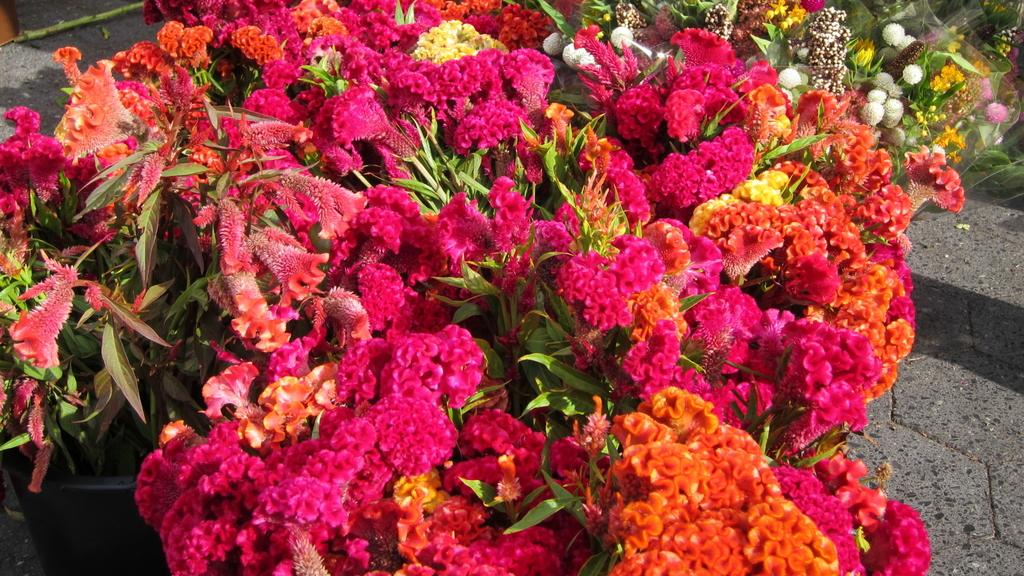What type of living organisms can be seen in the image? There are flowers and plants in the image. Can you describe the plants in the image? The plants in the image are not specified, but they are present alongside the flowers. What territory does the dad claim in the image? There is no mention of a dad or territory in the image; it features flowers and plants. How many screws are visible in the image? There are no screws present in the image. 